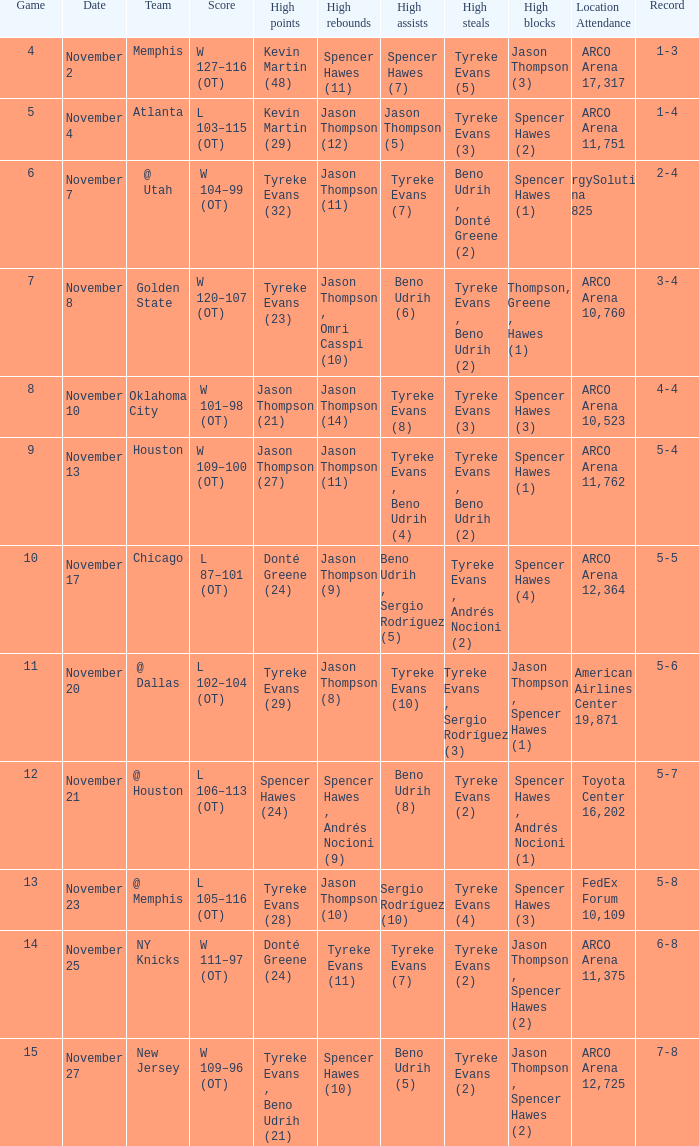If the record is 6-8, what was the score? W 111–97 (OT). 